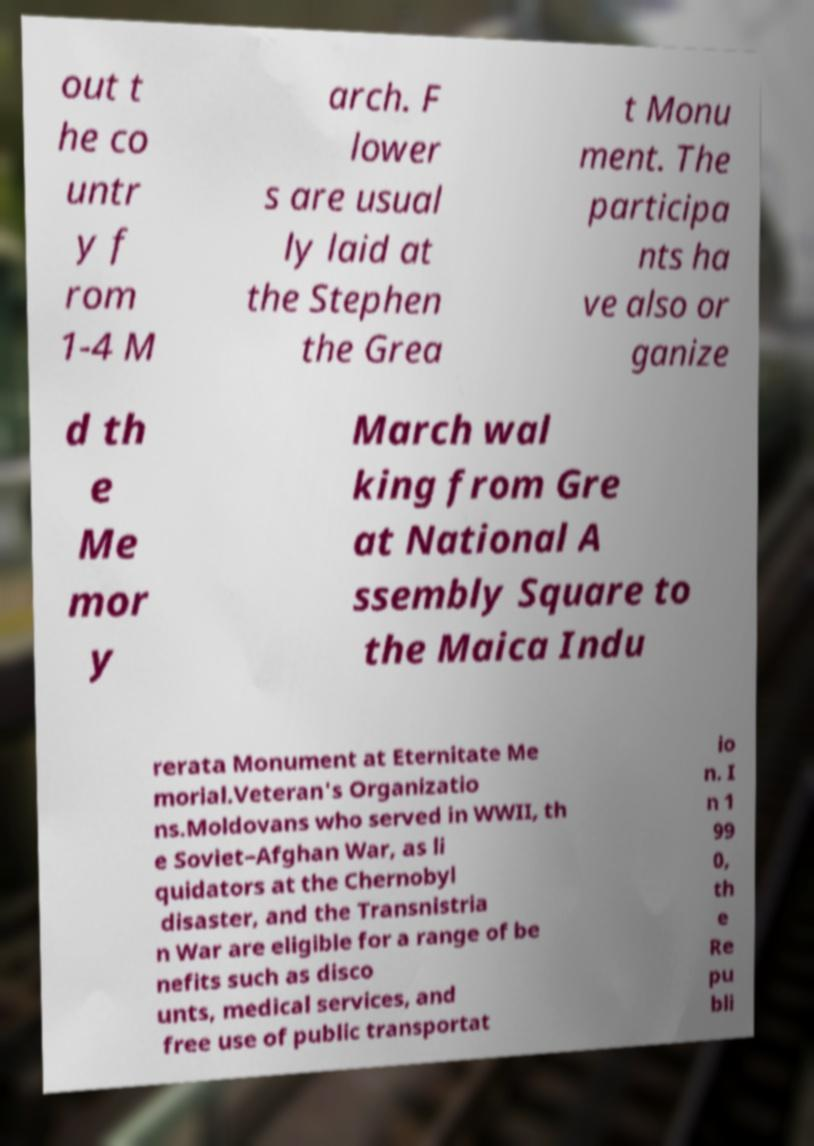There's text embedded in this image that I need extracted. Can you transcribe it verbatim? out t he co untr y f rom 1-4 M arch. F lower s are usual ly laid at the Stephen the Grea t Monu ment. The participa nts ha ve also or ganize d th e Me mor y March wal king from Gre at National A ssembly Square to the Maica Indu rerata Monument at Eternitate Me morial.Veteran's Organizatio ns.Moldovans who served in WWII, th e Soviet–Afghan War, as li quidators at the Chernobyl disaster, and the Transnistria n War are eligible for a range of be nefits such as disco unts, medical services, and free use of public transportat io n. I n 1 99 0, th e Re pu bli 